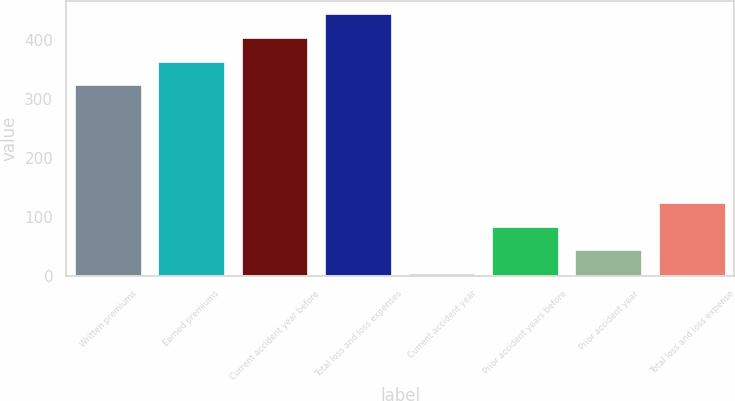Convert chart to OTSL. <chart><loc_0><loc_0><loc_500><loc_500><bar_chart><fcel>Written premiums<fcel>Earned premiums<fcel>Current accident year before<fcel>Total loss and loss expenses<fcel>Current accident year<fcel>Prior accident years before<fcel>Prior accident year<fcel>Total loss and loss expense<nl><fcel>323<fcel>362.94<fcel>402.88<fcel>442.82<fcel>3.64<fcel>83.52<fcel>43.58<fcel>123.5<nl></chart> 